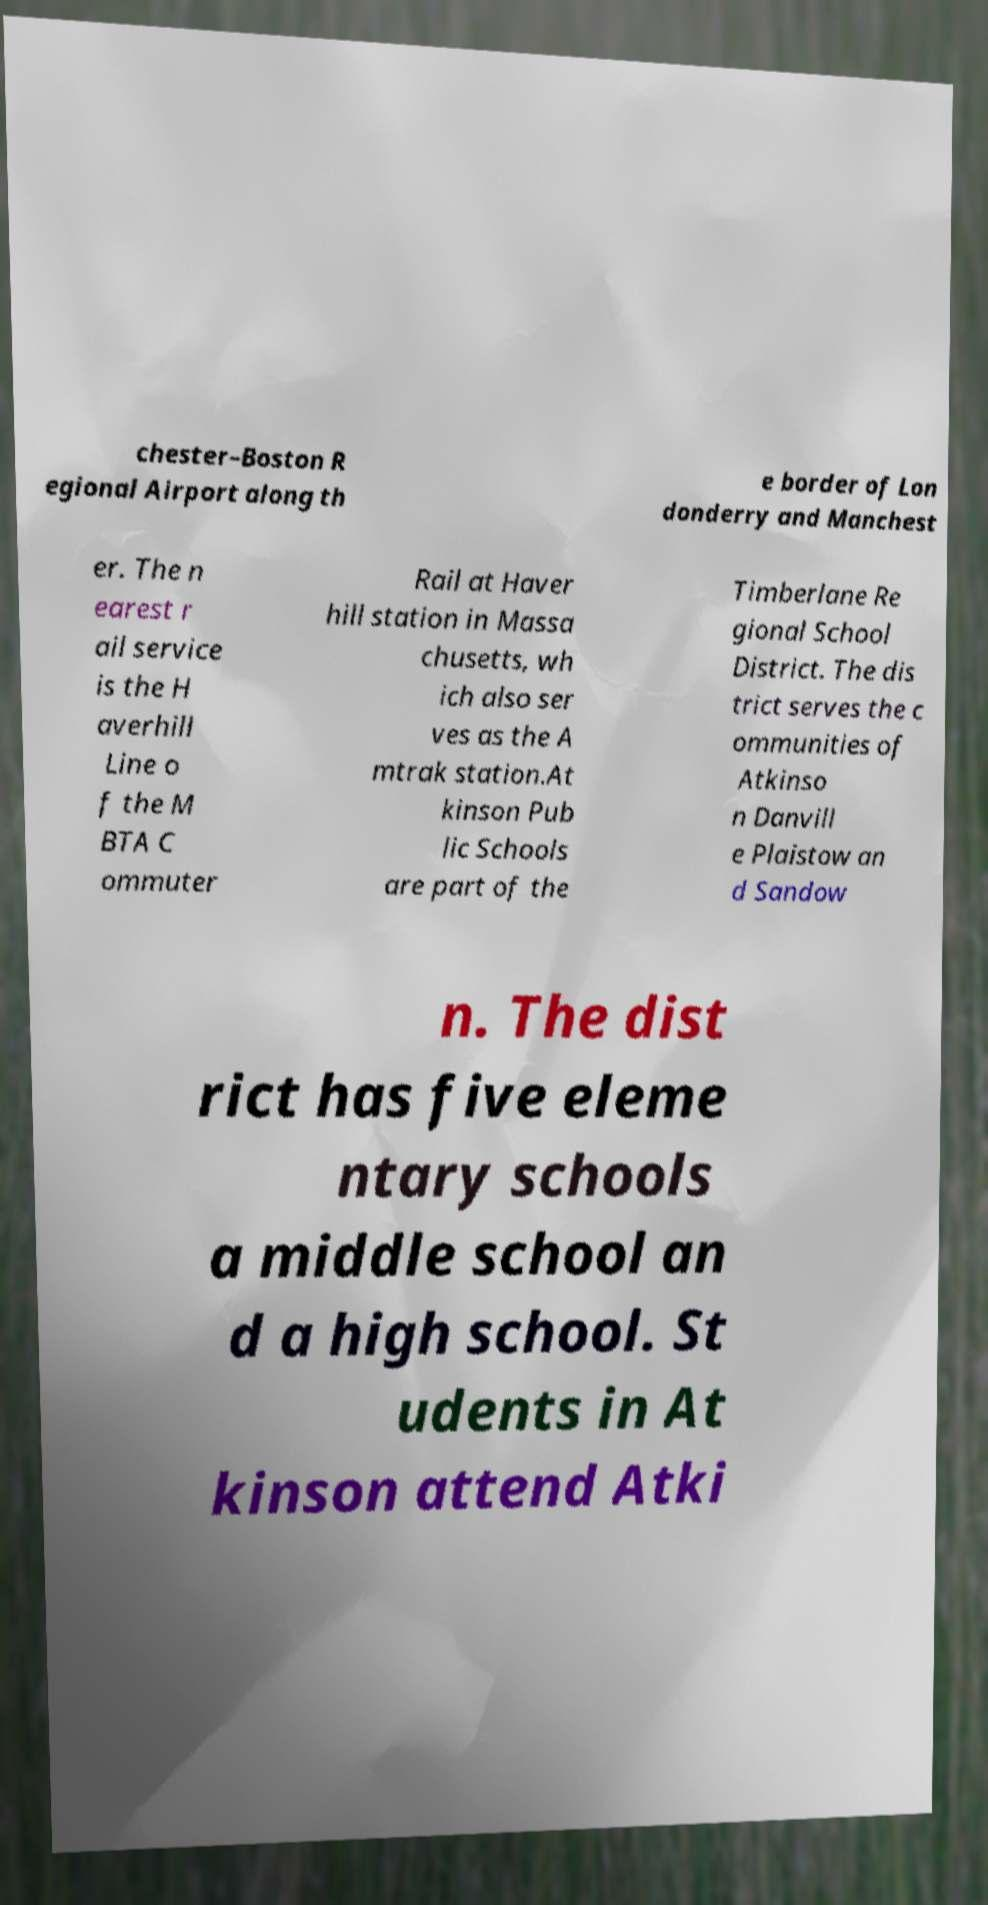Please read and relay the text visible in this image. What does it say? chester–Boston R egional Airport along th e border of Lon donderry and Manchest er. The n earest r ail service is the H averhill Line o f the M BTA C ommuter Rail at Haver hill station in Massa chusetts, wh ich also ser ves as the A mtrak station.At kinson Pub lic Schools are part of the Timberlane Re gional School District. The dis trict serves the c ommunities of Atkinso n Danvill e Plaistow an d Sandow n. The dist rict has five eleme ntary schools a middle school an d a high school. St udents in At kinson attend Atki 